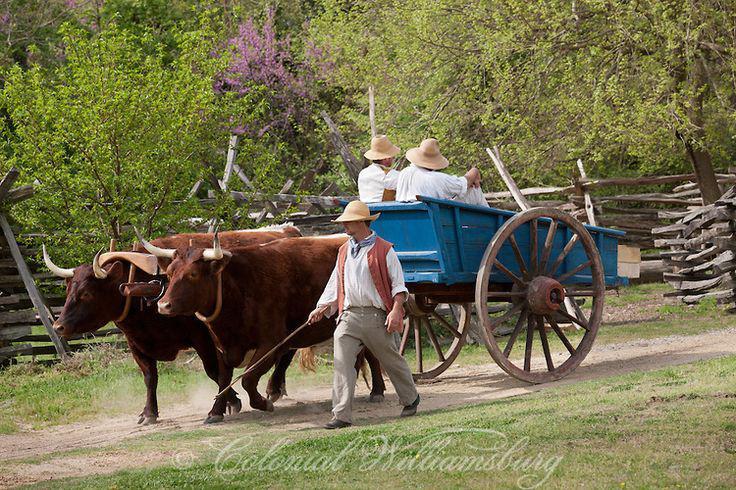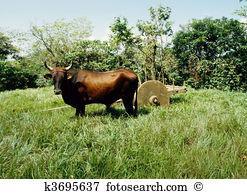The first image is the image on the left, the second image is the image on the right. Given the left and right images, does the statement "a pair of oxen are pulling a cart down a dirt path" hold true? Answer yes or no. Yes. The first image is the image on the left, the second image is the image on the right. Examine the images to the left and right. Is the description "The image on the right shows a single ox drawing a cart." accurate? Answer yes or no. Yes. 